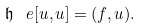Convert formula to latex. <formula><loc_0><loc_0><loc_500><loc_500>\mathfrak { h } _ { \ } e [ u , u ] = ( f , u ) .</formula> 